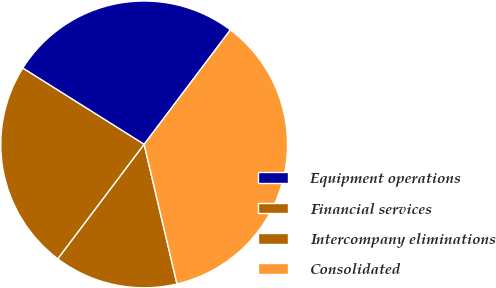Convert chart to OTSL. <chart><loc_0><loc_0><loc_500><loc_500><pie_chart><fcel>Equipment operations<fcel>Financial services<fcel>Intercompany eliminations<fcel>Consolidated<nl><fcel>26.35%<fcel>23.65%<fcel>13.96%<fcel>36.04%<nl></chart> 